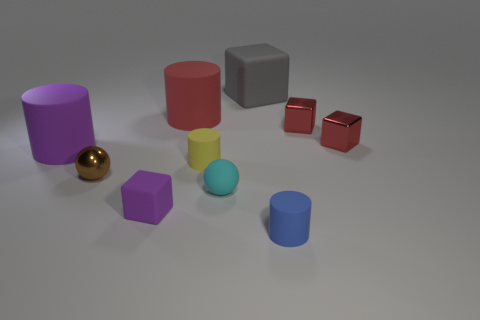Subtract all yellow spheres. How many red blocks are left? 2 Subtract all purple blocks. How many blocks are left? 3 Subtract 2 blocks. How many blocks are left? 2 Subtract all gray cubes. How many cubes are left? 3 Subtract all cubes. How many objects are left? 6 Subtract all cyan blocks. Subtract all purple cylinders. How many blocks are left? 4 Subtract all large brown rubber things. Subtract all yellow things. How many objects are left? 9 Add 8 brown metallic balls. How many brown metallic balls are left? 9 Add 1 small purple blocks. How many small purple blocks exist? 2 Subtract 0 brown cylinders. How many objects are left? 10 